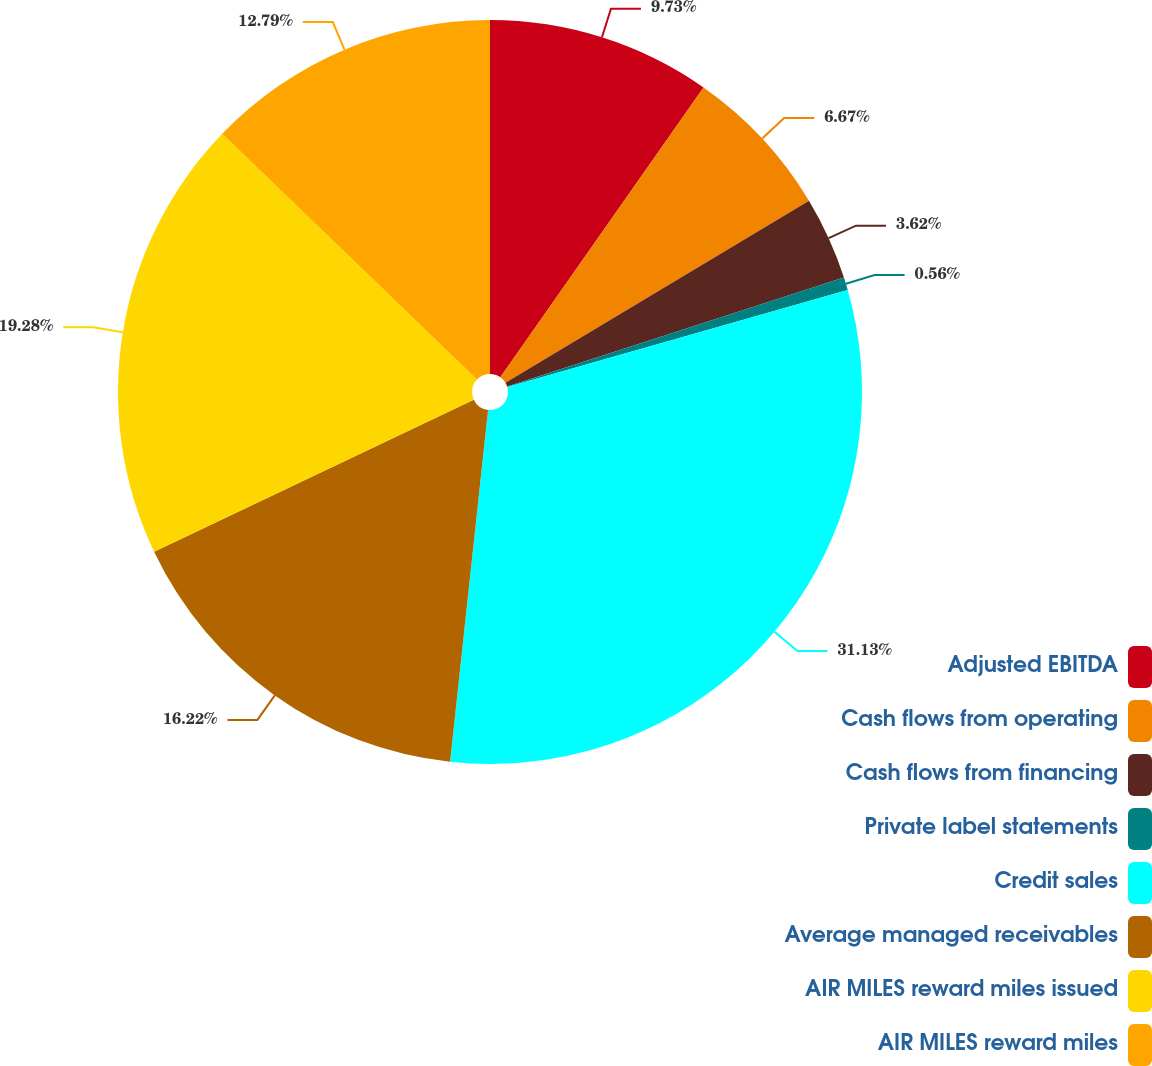Convert chart to OTSL. <chart><loc_0><loc_0><loc_500><loc_500><pie_chart><fcel>Adjusted EBITDA<fcel>Cash flows from operating<fcel>Cash flows from financing<fcel>Private label statements<fcel>Credit sales<fcel>Average managed receivables<fcel>AIR MILES reward miles issued<fcel>AIR MILES reward miles<nl><fcel>9.73%<fcel>6.67%<fcel>3.62%<fcel>0.56%<fcel>31.13%<fcel>16.22%<fcel>19.28%<fcel>12.79%<nl></chart> 